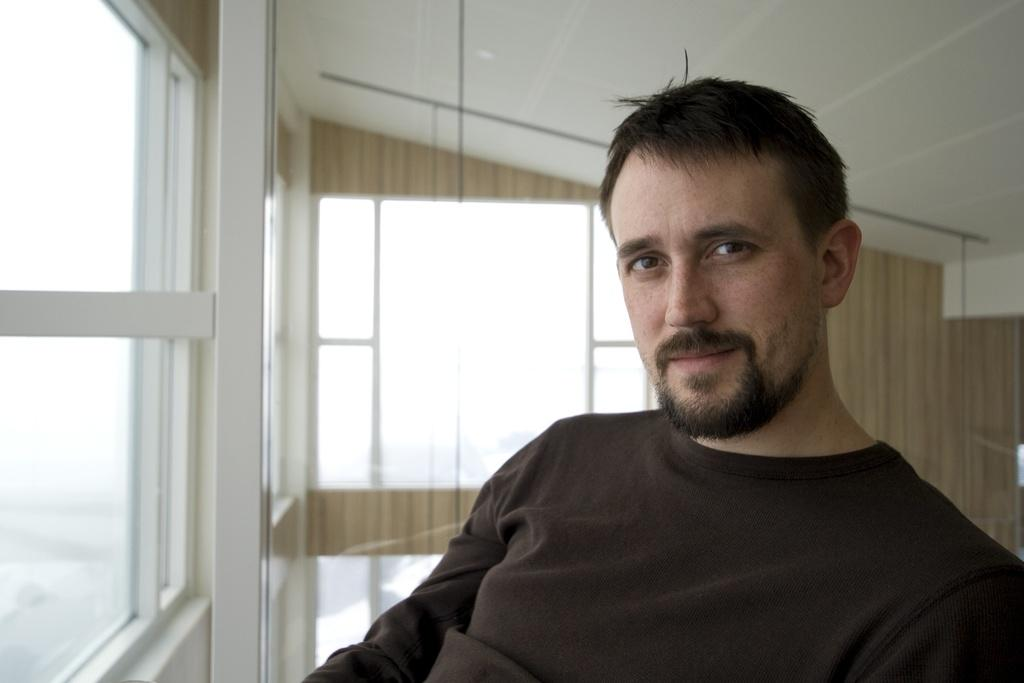Who is present in the image? There is a man in the image. What is the man wearing? The man is wearing a T-shirt. What type of material is used for the windows in the image? There are glass windows in the image. What word does the man say in the image? There is no indication of the man speaking or saying any word in the image. 